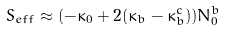Convert formula to latex. <formula><loc_0><loc_0><loc_500><loc_500>S _ { e f f } \approx ( - \kappa _ { 0 } + 2 ( \kappa _ { b } - \kappa _ { b } ^ { c } ) ) N _ { 0 } ^ { b }</formula> 